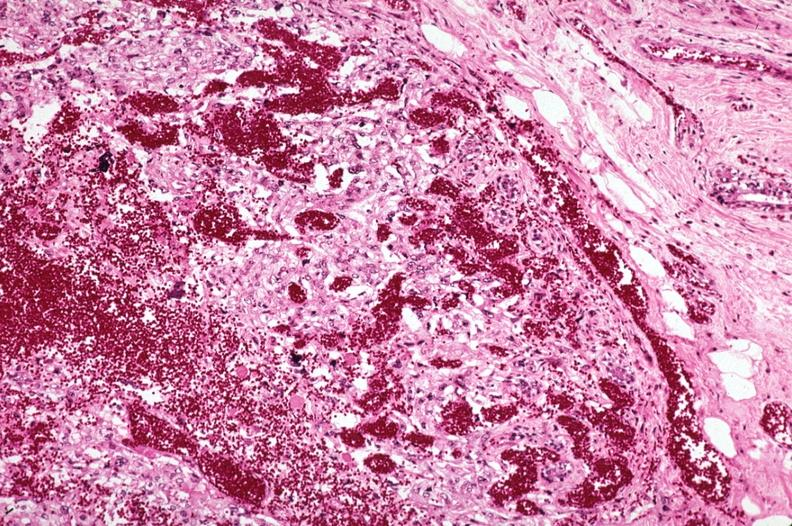s opened muscle present?
Answer the question using a single word or phrase. No 